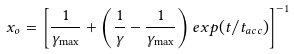Convert formula to latex. <formula><loc_0><loc_0><loc_500><loc_500>x _ { o } = \left [ \frac { 1 } { \gamma _ { \max } } + \left ( \frac { 1 } { \gamma } - \frac { 1 } { \gamma _ { \max } } \right ) e x p ( t / t _ { a c c } ) \right ] ^ { - 1 }</formula> 